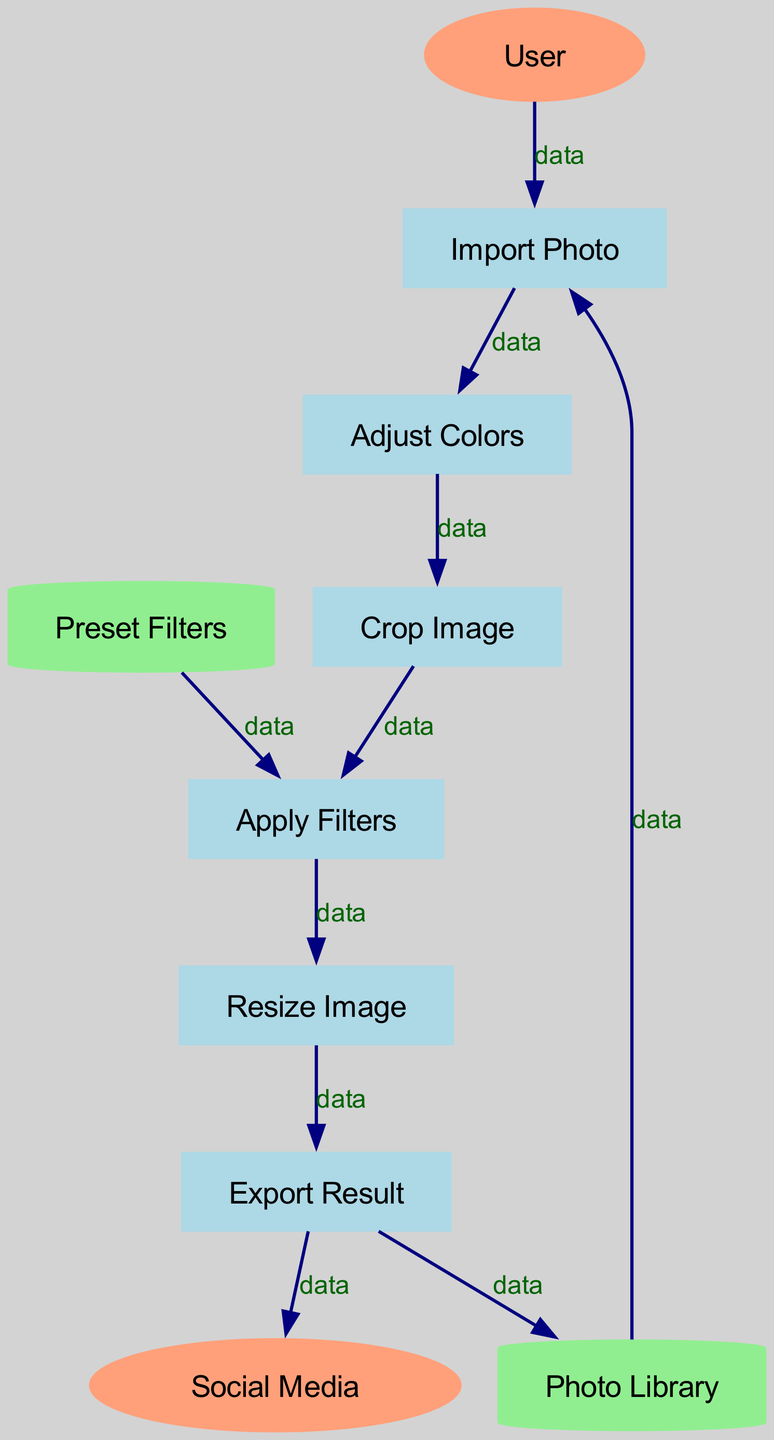What is the first process in the diagram? The first process in the diagram is identified as "Import Photo," which is the starting point of the digital photo editing workflow.
Answer: Import Photo How many processes are shown in the diagram? The diagram lists a total of six processes: Import Photo, Adjust Colors, Crop Image, Apply Filters, Resize Image, and Export Result. Counting these gives us six processes.
Answer: 6 What data store is linked to “Apply Filters”? The data flow indicates a connection from "Preset Filters" to "Apply Filters," showing that "Apply Filters" utilizes data from this store.
Answer: Preset Filters Which external entity is connected to “Export Result”? The flow from "Export Result" leads to the external entity "Social Media," indicating that the result of the editing is shared or exported to this entity.
Answer: Social Media What is the relationship between “Crop Image” and “Adjust Colors”? The flow connects "Adjust Colors" to "Crop Image," indicating that after adjusting colors, the next step is to crop the image. Thus, "Crop Image" follows "Adjust Colors" in the workflow.
Answer: Adjust Colors → Crop Image What process follows “Resize Image”? The workflow shows that after "Resize Image," the next process is "Export Result," indicating that resizing is completed before exporting the final edited image.
Answer: Export Result How many data flows are there in the diagram? By examining the data flows shown, there are a total of ten connections specified in the diagram, representing the data transfer between entities, processes, and data stores.
Answer: 10 Which process is dependent on the “Photo Library”? The process "Import Photo" relies on data from the "Photo Library," as indicated by the flow that connects these two elements.
Answer: Import Photo What is the function of “Photo Library” in the workflow? The "Photo Library" acts as a data store that provides photos for the "Import Photo" process, indicating its role in supplying the initial data needed for editing.
Answer: Data store for photos What shape represents external entities in the diagram? External entities are represented by ellipses in the diagram, a standard shape used in data flow diagrams to denote external components that interact with the system.
Answer: Ellipse 